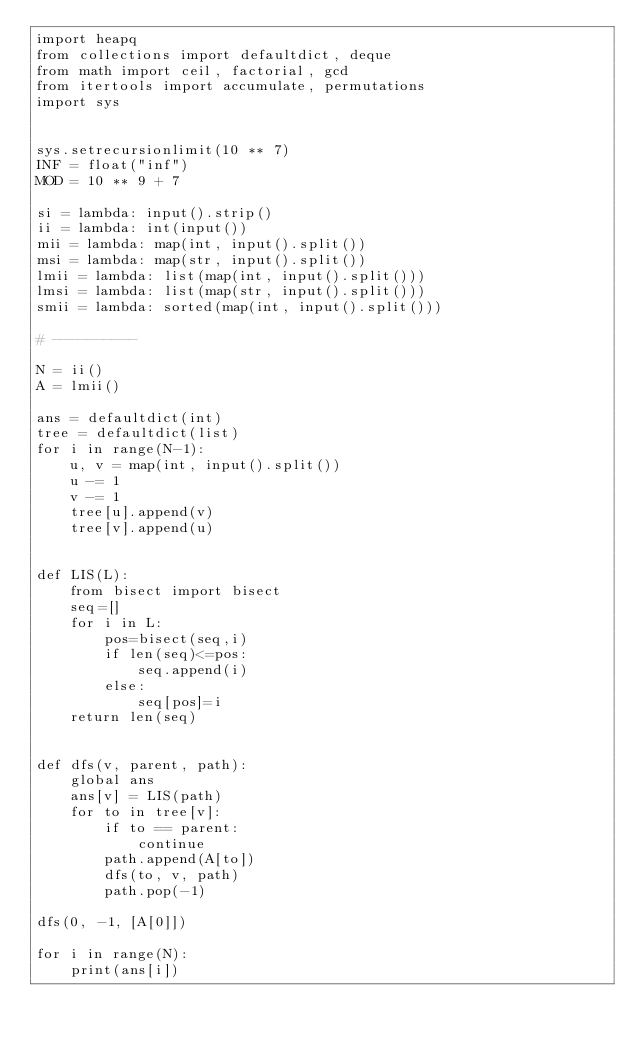Convert code to text. <code><loc_0><loc_0><loc_500><loc_500><_Python_>import heapq
from collections import defaultdict, deque
from math import ceil, factorial, gcd
from itertools import accumulate, permutations
import sys


sys.setrecursionlimit(10 ** 7)
INF = float("inf")
MOD = 10 ** 9 + 7

si = lambda: input().strip()
ii = lambda: int(input())
mii = lambda: map(int, input().split())
msi = lambda: map(str, input().split())
lmii = lambda: list(map(int, input().split()))
lmsi = lambda: list(map(str, input().split()))
smii = lambda: sorted(map(int, input().split()))

# ----------

N = ii()
A = lmii()

ans = defaultdict(int)
tree = defaultdict(list)
for i in range(N-1):
    u, v = map(int, input().split())
    u -= 1
    v -= 1
    tree[u].append(v)
    tree[v].append(u)


def LIS(L):
    from bisect import bisect
    seq=[]
    for i in L:
        pos=bisect(seq,i)
        if len(seq)<=pos:
            seq.append(i)
        else:
            seq[pos]=i
    return len(seq)


def dfs(v, parent, path):
    global ans
    ans[v] = LIS(path)
    for to in tree[v]:
        if to == parent:
            continue
        path.append(A[to])
        dfs(to, v, path)
        path.pop(-1)

dfs(0, -1, [A[0]])

for i in range(N):
    print(ans[i])</code> 